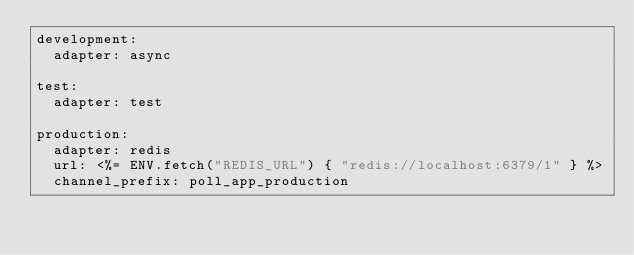Convert code to text. <code><loc_0><loc_0><loc_500><loc_500><_YAML_>development:
  adapter: async

test:
  adapter: test

production:
  adapter: redis
  url: <%= ENV.fetch("REDIS_URL") { "redis://localhost:6379/1" } %>
  channel_prefix: poll_app_production
</code> 